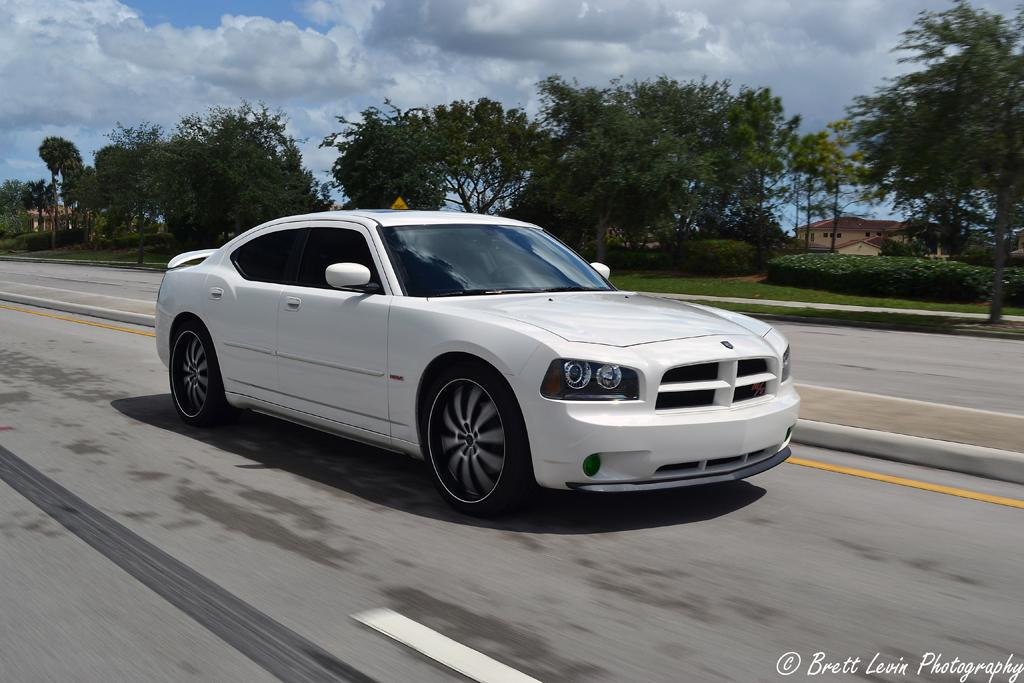What is the main subject of the image? The main subject of the image is a car. What color is the car? The car is white in color. What is the car doing in the image? The car is moving on a road. What can be seen in the background of the image? There are trees, a house, and a cloudy sky in the background of the image. What type of division is taking place in the image? There is no division taking place in the image; it features a car moving on a road with a background of trees, a house, and a cloudy sky. What role does zinc play in the image? There is no mention of zinc in the image; it is a car moving on a road with a background of trees, a house, and a cloudy sky. 